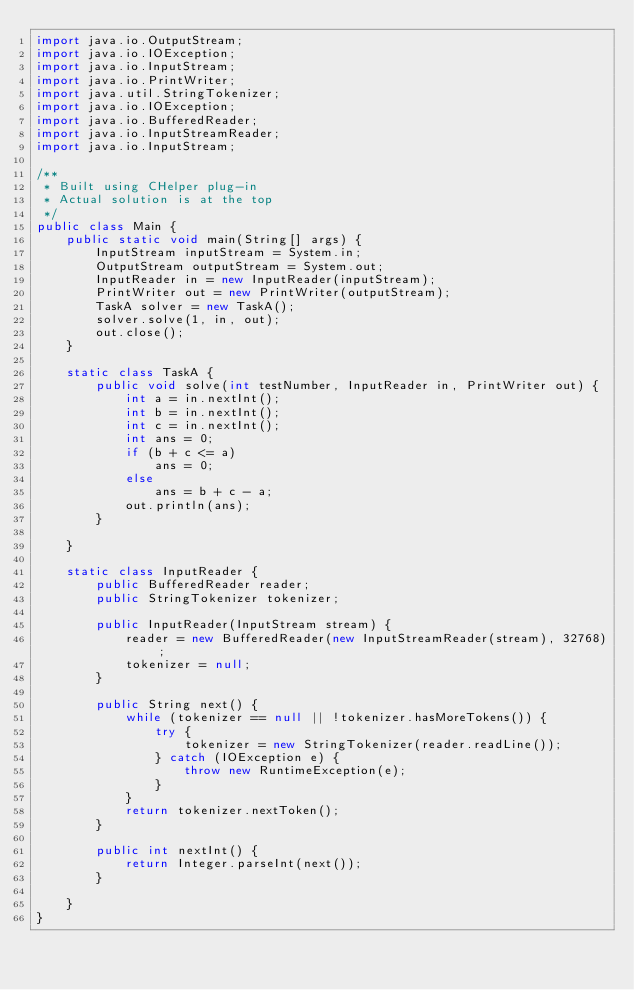<code> <loc_0><loc_0><loc_500><loc_500><_Java_>import java.io.OutputStream;
import java.io.IOException;
import java.io.InputStream;
import java.io.PrintWriter;
import java.util.StringTokenizer;
import java.io.IOException;
import java.io.BufferedReader;
import java.io.InputStreamReader;
import java.io.InputStream;

/**
 * Built using CHelper plug-in
 * Actual solution is at the top
 */
public class Main {
    public static void main(String[] args) {
        InputStream inputStream = System.in;
        OutputStream outputStream = System.out;
        InputReader in = new InputReader(inputStream);
        PrintWriter out = new PrintWriter(outputStream);
        TaskA solver = new TaskA();
        solver.solve(1, in, out);
        out.close();
    }

    static class TaskA {
        public void solve(int testNumber, InputReader in, PrintWriter out) {
            int a = in.nextInt();
            int b = in.nextInt();
            int c = in.nextInt();
            int ans = 0;
            if (b + c <= a)
                ans = 0;
            else
                ans = b + c - a;
            out.println(ans);
        }

    }

    static class InputReader {
        public BufferedReader reader;
        public StringTokenizer tokenizer;

        public InputReader(InputStream stream) {
            reader = new BufferedReader(new InputStreamReader(stream), 32768);
            tokenizer = null;
        }

        public String next() {
            while (tokenizer == null || !tokenizer.hasMoreTokens()) {
                try {
                    tokenizer = new StringTokenizer(reader.readLine());
                } catch (IOException e) {
                    throw new RuntimeException(e);
                }
            }
            return tokenizer.nextToken();
        }

        public int nextInt() {
            return Integer.parseInt(next());
        }

    }
}

</code> 